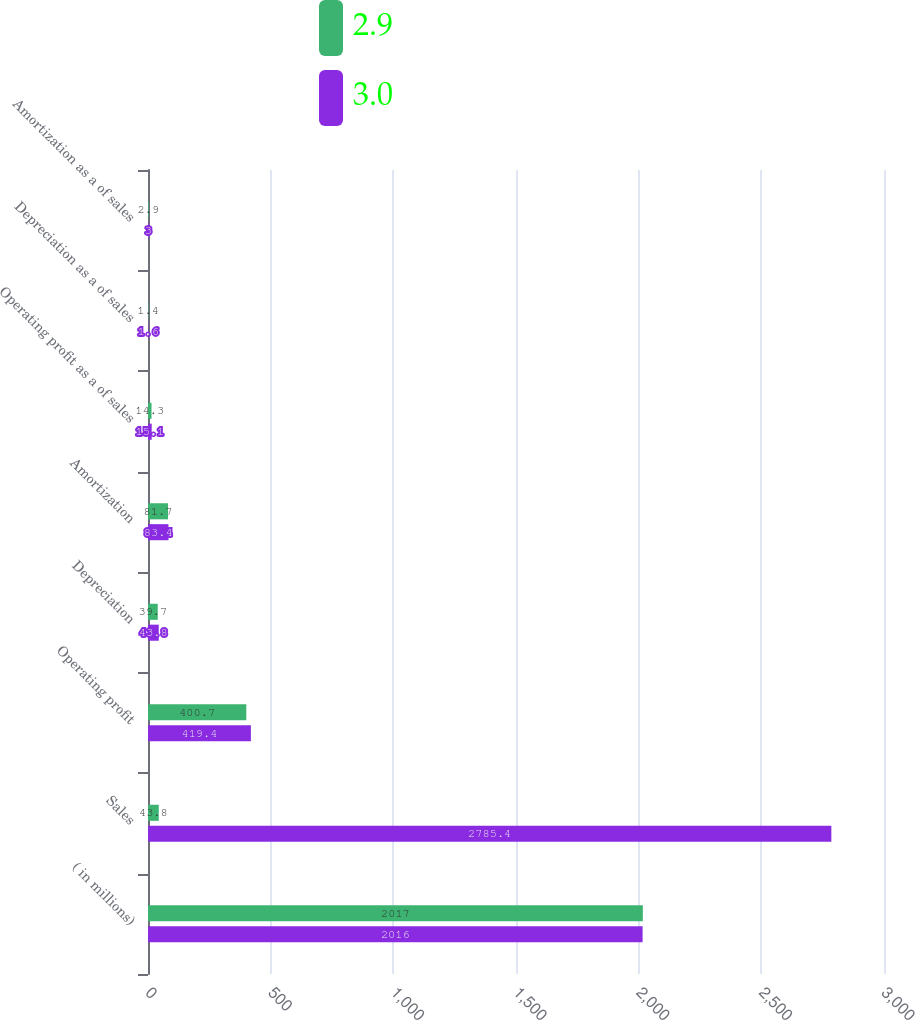Convert chart to OTSL. <chart><loc_0><loc_0><loc_500><loc_500><stacked_bar_chart><ecel><fcel>( in millions)<fcel>Sales<fcel>Operating profit<fcel>Depreciation<fcel>Amortization<fcel>Operating profit as a of sales<fcel>Depreciation as a of sales<fcel>Amortization as a of sales<nl><fcel>2.9<fcel>2017<fcel>43.8<fcel>400.7<fcel>39.7<fcel>81.7<fcel>14.3<fcel>1.4<fcel>2.9<nl><fcel>3<fcel>2016<fcel>2785.4<fcel>419.4<fcel>43.8<fcel>83.4<fcel>15.1<fcel>1.6<fcel>3<nl></chart> 